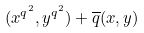Convert formula to latex. <formula><loc_0><loc_0><loc_500><loc_500>( x ^ { q ^ { 2 } } , y ^ { q ^ { 2 } } ) + \overline { q } ( x , y )</formula> 